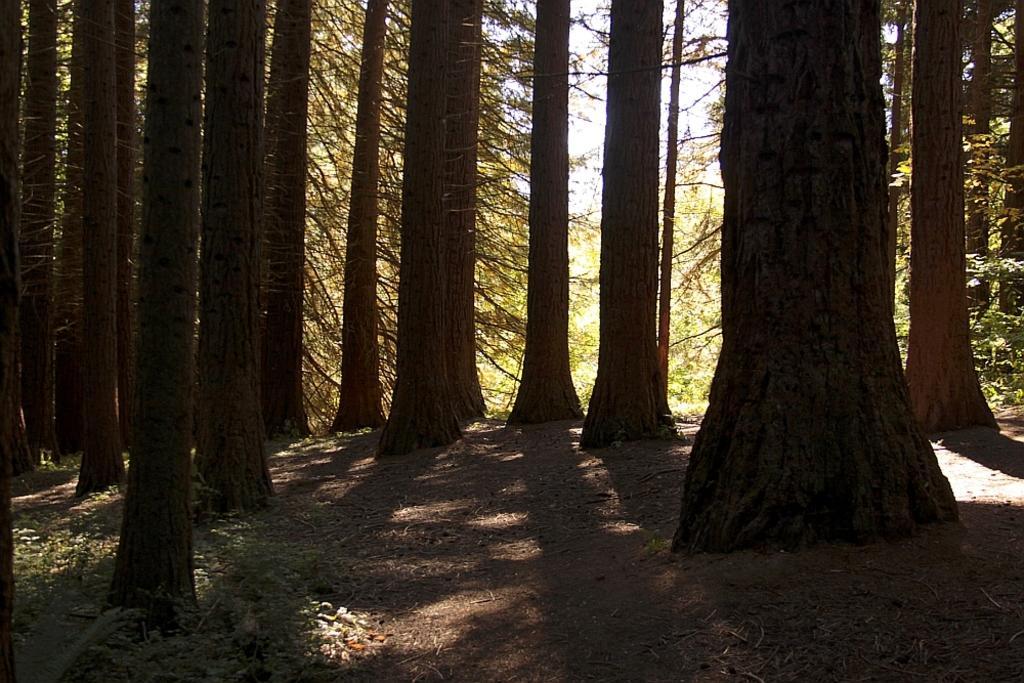Describe this image in one or two sentences. In the foreground of this picture, there are many trees and in the background, we can see the sky. 